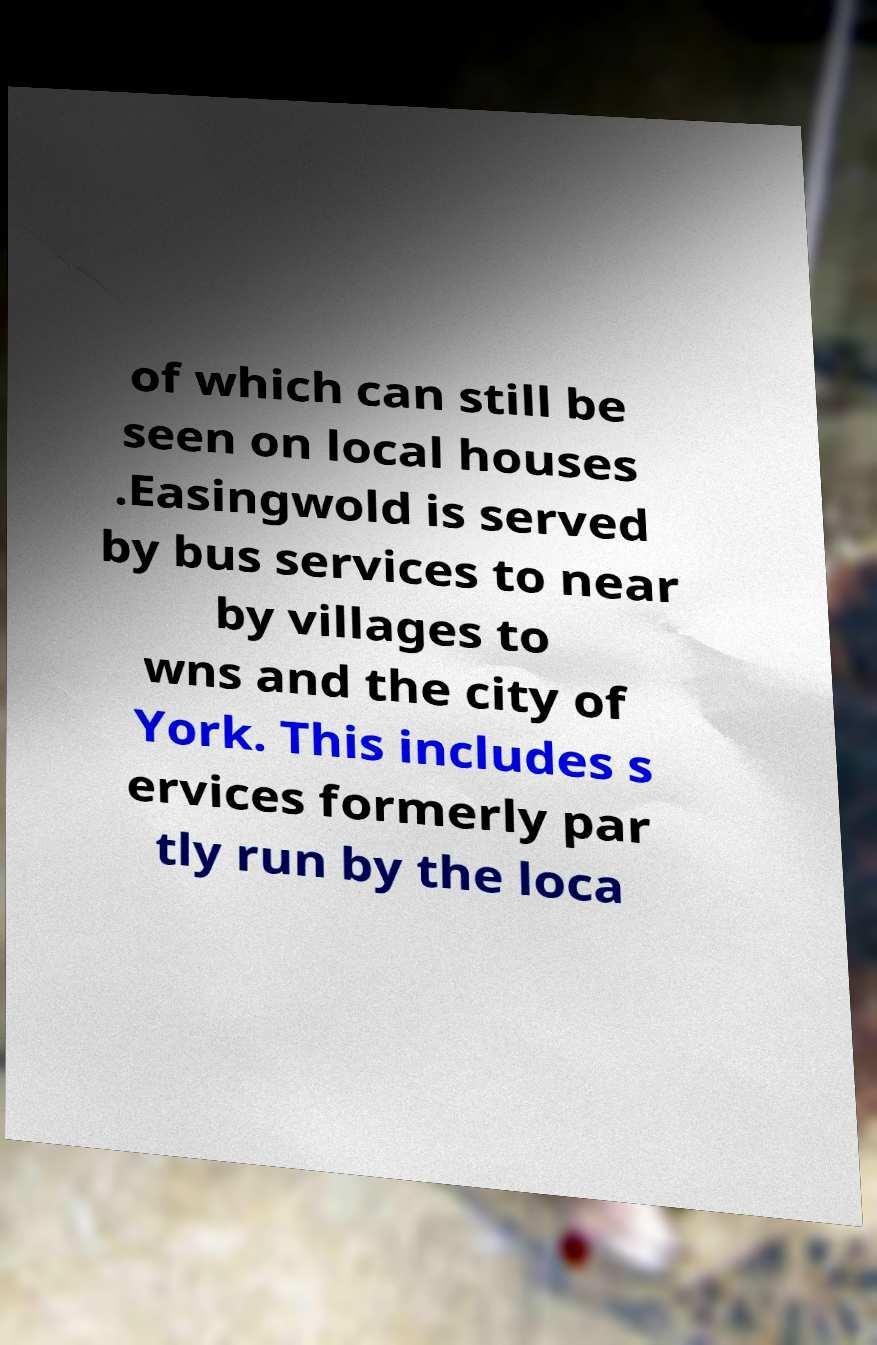Can you accurately transcribe the text from the provided image for me? of which can still be seen on local houses .Easingwold is served by bus services to near by villages to wns and the city of York. This includes s ervices formerly par tly run by the loca 